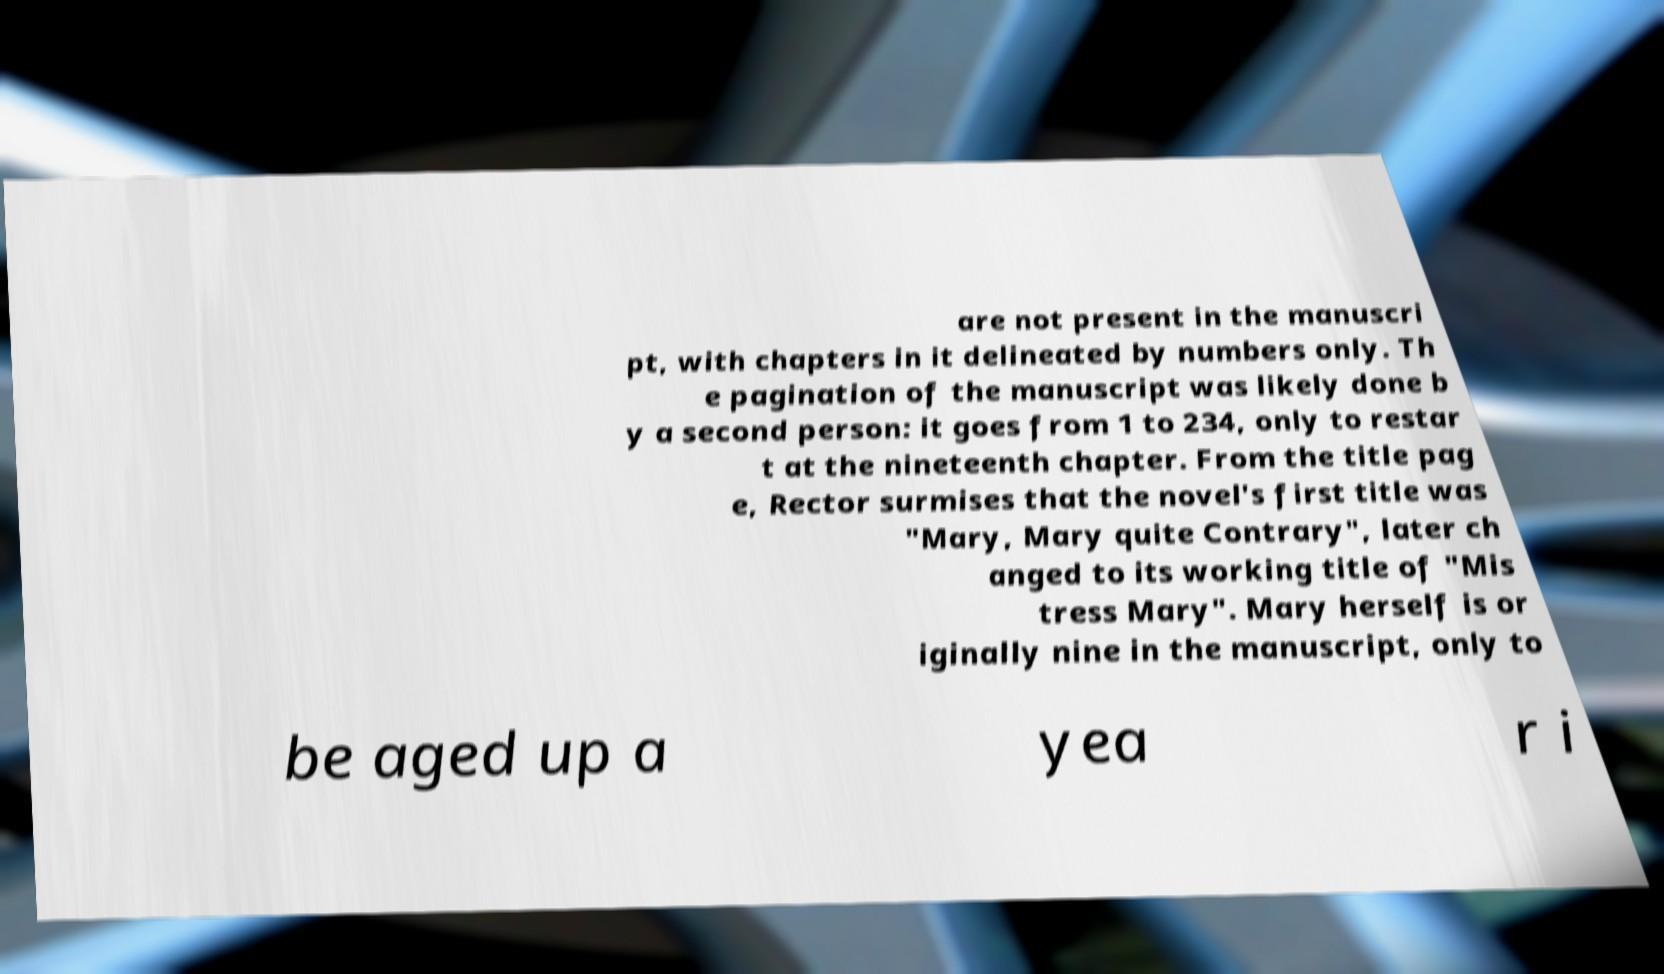Please identify and transcribe the text found in this image. are not present in the manuscri pt, with chapters in it delineated by numbers only. Th e pagination of the manuscript was likely done b y a second person: it goes from 1 to 234, only to restar t at the nineteenth chapter. From the title pag e, Rector surmises that the novel's first title was "Mary, Mary quite Contrary", later ch anged to its working title of "Mis tress Mary". Mary herself is or iginally nine in the manuscript, only to be aged up a yea r i 